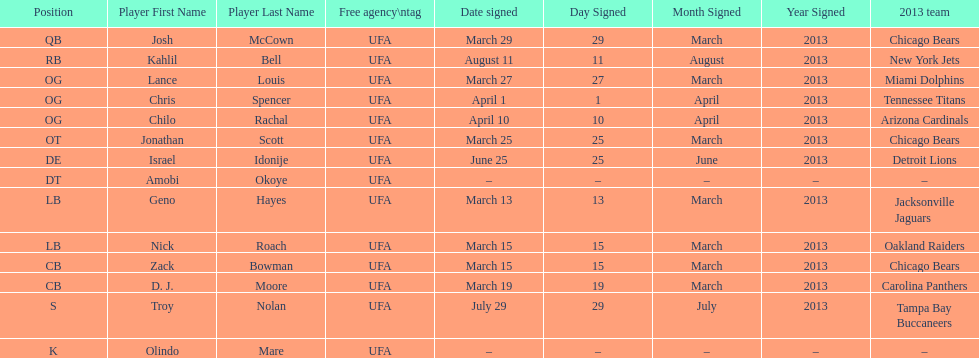The only player to sign in july? Troy Nolan. 